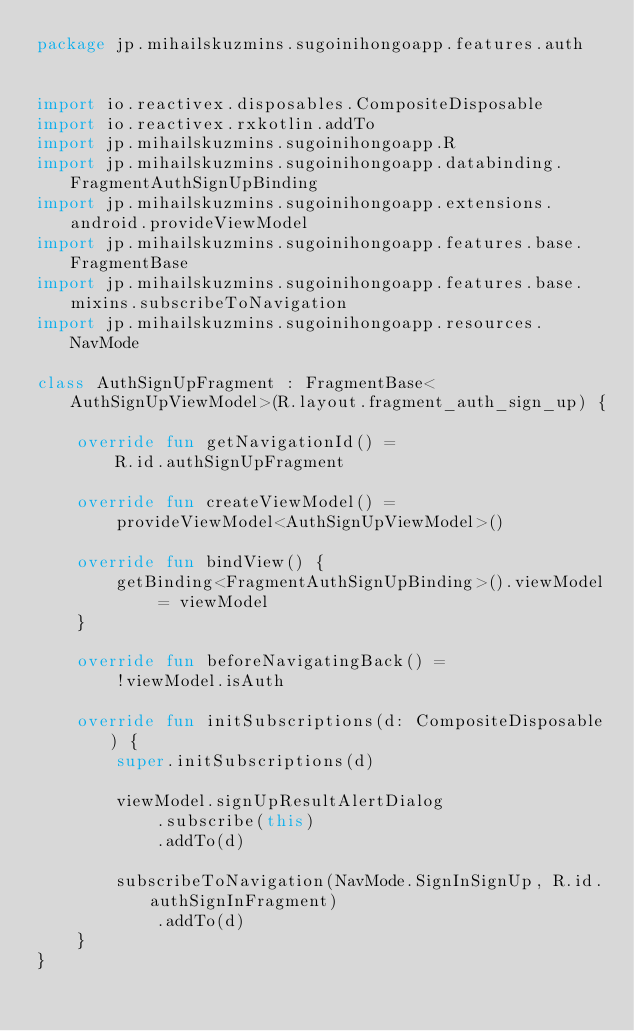<code> <loc_0><loc_0><loc_500><loc_500><_Kotlin_>package jp.mihailskuzmins.sugoinihongoapp.features.auth


import io.reactivex.disposables.CompositeDisposable
import io.reactivex.rxkotlin.addTo
import jp.mihailskuzmins.sugoinihongoapp.R
import jp.mihailskuzmins.sugoinihongoapp.databinding.FragmentAuthSignUpBinding
import jp.mihailskuzmins.sugoinihongoapp.extensions.android.provideViewModel
import jp.mihailskuzmins.sugoinihongoapp.features.base.FragmentBase
import jp.mihailskuzmins.sugoinihongoapp.features.base.mixins.subscribeToNavigation
import jp.mihailskuzmins.sugoinihongoapp.resources.NavMode

class AuthSignUpFragment : FragmentBase<AuthSignUpViewModel>(R.layout.fragment_auth_sign_up) {

    override fun getNavigationId() =
        R.id.authSignUpFragment

    override fun createViewModel() =
        provideViewModel<AuthSignUpViewModel>()

    override fun bindView() {
        getBinding<FragmentAuthSignUpBinding>().viewModel = viewModel
    }

    override fun beforeNavigatingBack() =
        !viewModel.isAuth

    override fun initSubscriptions(d: CompositeDisposable) {
        super.initSubscriptions(d)

        viewModel.signUpResultAlertDialog
            .subscribe(this)
            .addTo(d)

        subscribeToNavigation(NavMode.SignInSignUp, R.id.authSignInFragment)
            .addTo(d)
    }
}
</code> 